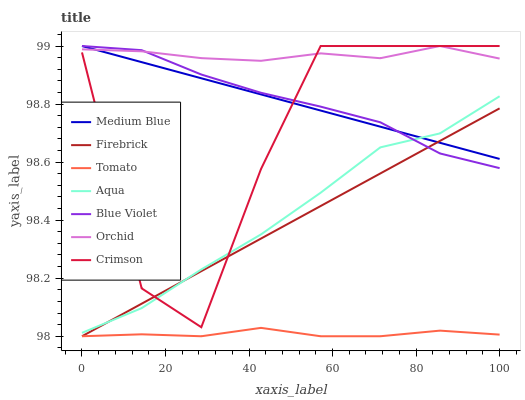Does Tomato have the minimum area under the curve?
Answer yes or no. Yes. Does Orchid have the maximum area under the curve?
Answer yes or no. Yes. Does Medium Blue have the minimum area under the curve?
Answer yes or no. No. Does Medium Blue have the maximum area under the curve?
Answer yes or no. No. Is Firebrick the smoothest?
Answer yes or no. Yes. Is Crimson the roughest?
Answer yes or no. Yes. Is Medium Blue the smoothest?
Answer yes or no. No. Is Medium Blue the roughest?
Answer yes or no. No. Does Medium Blue have the lowest value?
Answer yes or no. No. Does Orchid have the highest value?
Answer yes or no. Yes. Does Firebrick have the highest value?
Answer yes or no. No. Is Tomato less than Medium Blue?
Answer yes or no. Yes. Is Orchid greater than Aqua?
Answer yes or no. Yes. Does Orchid intersect Crimson?
Answer yes or no. Yes. Is Orchid less than Crimson?
Answer yes or no. No. Is Orchid greater than Crimson?
Answer yes or no. No. Does Tomato intersect Medium Blue?
Answer yes or no. No. 